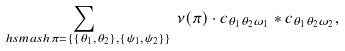<formula> <loc_0><loc_0><loc_500><loc_500>\sum _ { \ h s m a s h { \pi = \{ \{ \theta _ { 1 } , \theta _ { 2 } \} , \{ \psi _ { 1 } , \psi _ { 2 } \} \} } } \, \nu ( \pi ) \cdot c _ { \theta _ { 1 } \theta _ { 2 } \omega _ { 1 } } * c _ { \theta _ { 1 } \theta _ { 2 } \omega _ { 2 } } ,</formula> 